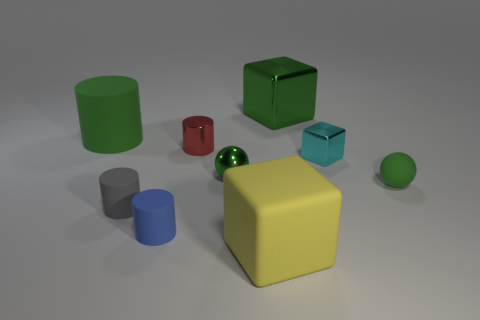Subtract all yellow spheres. Subtract all purple blocks. How many spheres are left? 2 Add 1 green things. How many objects exist? 10 Subtract all spheres. How many objects are left? 7 Subtract 1 red cylinders. How many objects are left? 8 Subtract all brown cubes. Subtract all small blocks. How many objects are left? 8 Add 2 small rubber spheres. How many small rubber spheres are left? 3 Add 1 green shiny balls. How many green shiny balls exist? 2 